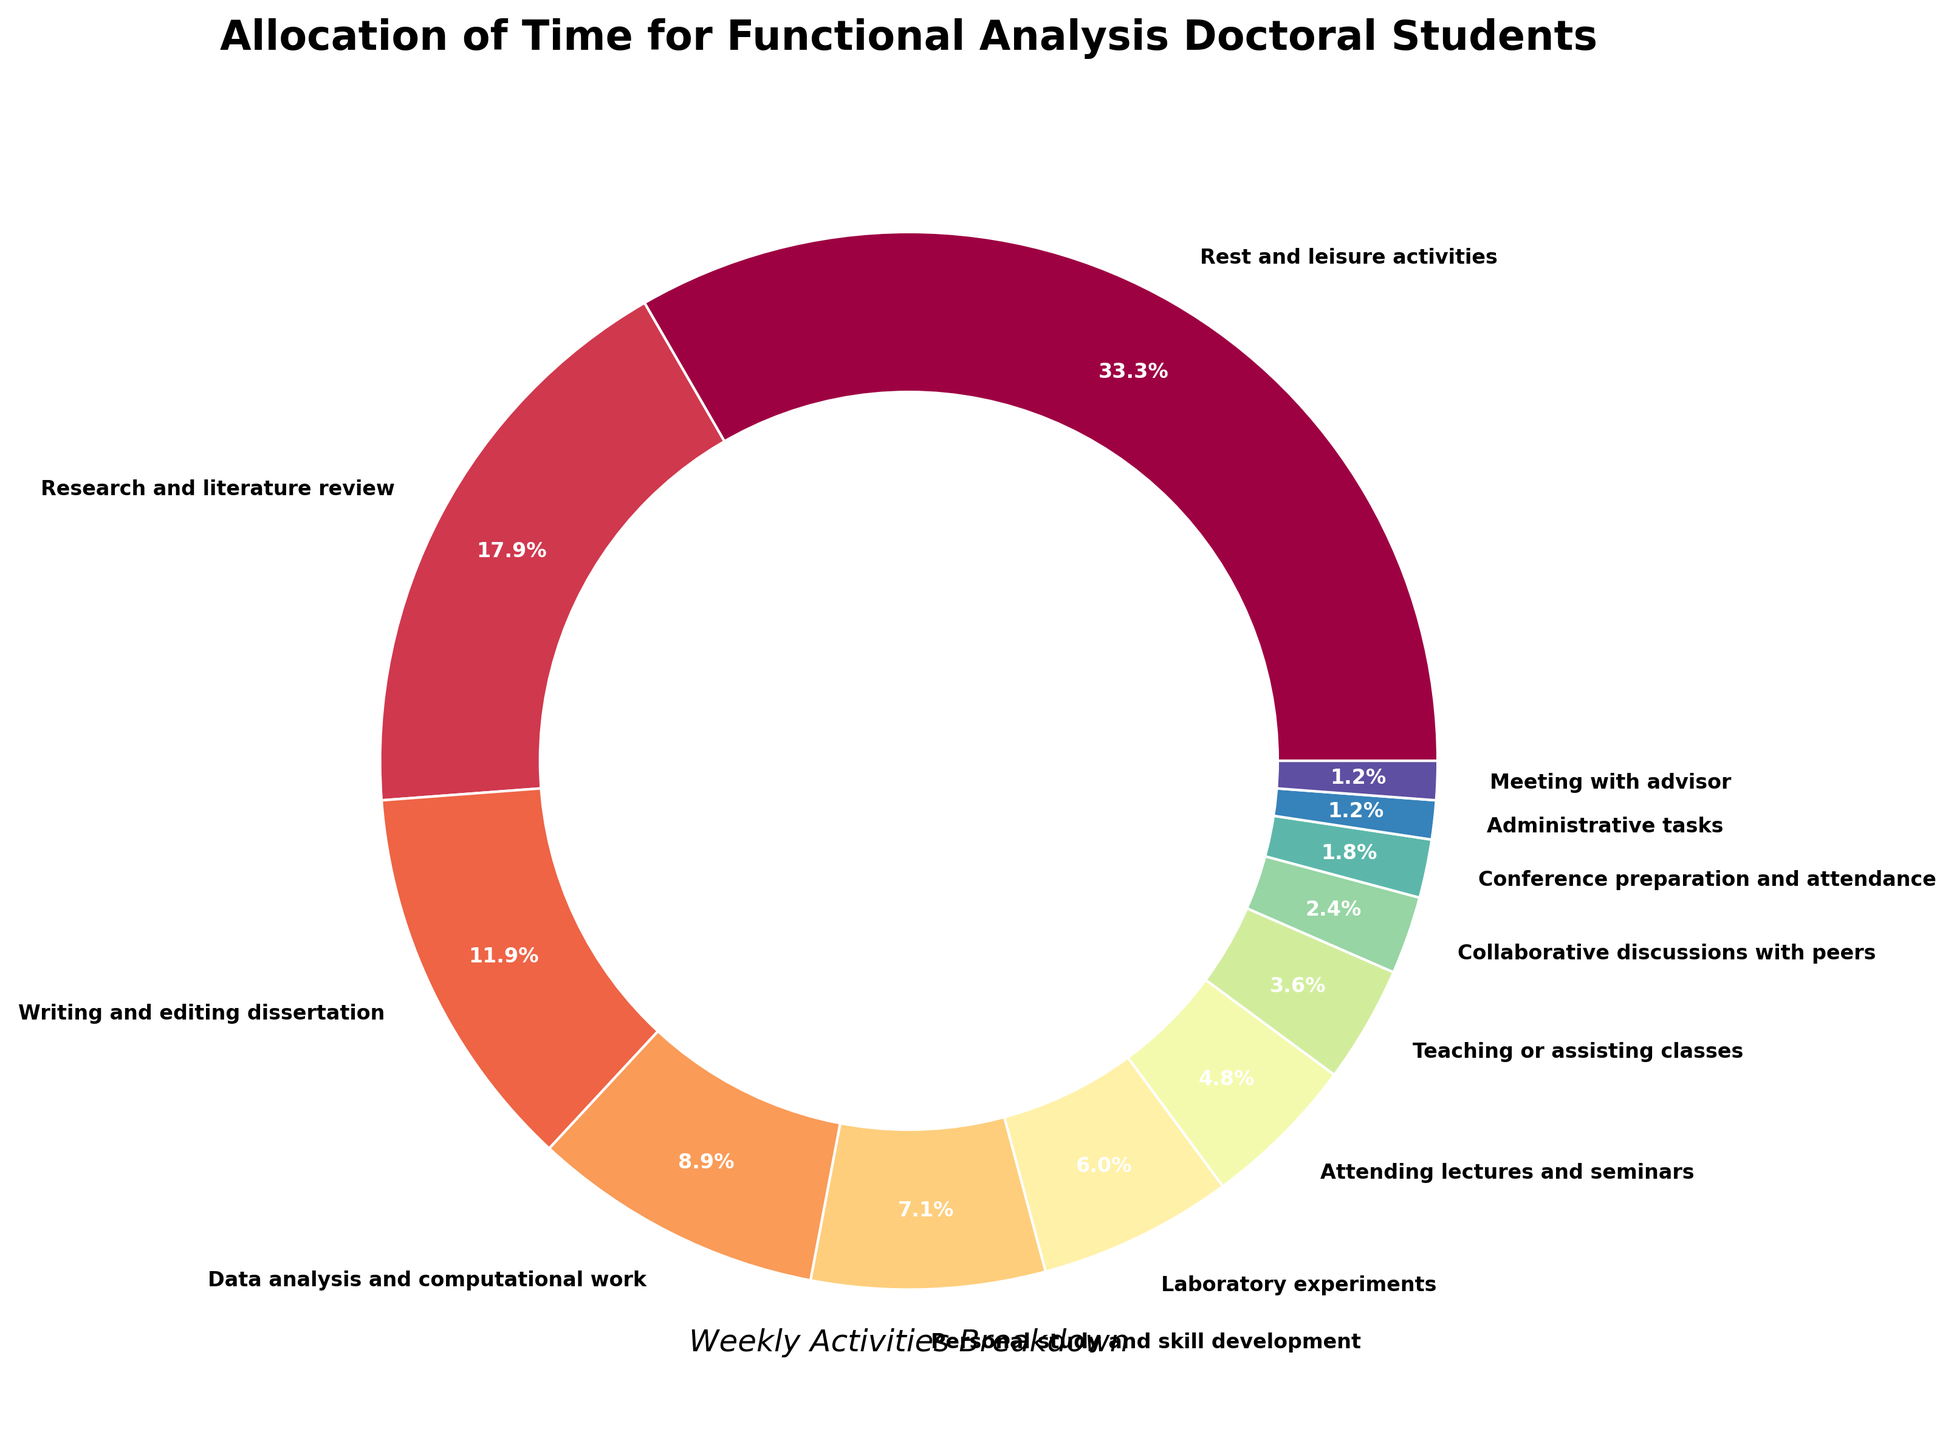What activity takes up the largest portion of time? The largest wedge in the pie chart represents "Rest and leisure activities", which is visually the largest section.
Answer: Rest and leisure activities Which two activities combined represent about as much time as writing and editing the dissertation? Writing and editing the dissertation takes 20 hours. "Data analysis and computational work" (15 hours) and "Meeting with advisor" (2 hours) together make 17 hours, which is about as much as writing and editing.
Answer: Data analysis and computational work, Meeting with advisor How much more time is spent on research and literature review compared to collaborative discussions with peers? Research and literature review takes up 30 hours while collaborative discussions with peers take 4 hours. The difference is 30 - 4 = 26 hours.
Answer: 26 hours What percentage of time is spent on both laboratory experiments and personal study combined? Laboratory experiments take up 10 hours and personal study and skill development takes 12 hours. The combined hours are 10 + 12 = 22 hours. Calculating the percentage: (22 / 168) * 100 ≈ 13.1%.
Answer: Approximately 13.1% What is the least time-consuming activity? The smallest wedge in the pie chart represents "Administrative tasks", occupying the least amount of time.
Answer: Administrative tasks Which activity, other than rest and leisure, consumes more time than attending lectures and seminars? "Attending lectures and seminars" takes 8 hours. Activities that consume more time are "Research and literature review" (30 hours), "Writing and editing dissertation" (20 hours), "Data analysis and computational work" (15 hours), "Laboratory experiments" (10 hours), and "Personal study and skill development" (12 hours).
Answer: Research and literature review, Writing and editing dissertation, Data analysis and computational work, Laboratory experiments, Personal study and skill development Which activities combined take up one third of the total weekly hours? The total weekly hours are 168. One third of 168 is 56 hours. "Rest and leisure activities" alone take 56 hours which is one third of the total weekly hours.
Answer: Rest and leisure activities Compare the time spent on teaching or assisting classes and meeting with advisor. Which one takes more time and by how many hours? "Teaching or assisting classes" takes 6 hours, whereas "Meeting with advisor" takes 2 hours. The difference is 6 - 2 = 4 hours.
Answer: Teaching or assisting classes, 4 hours What fraction of the total weekly hours is dedicated to attending lectures and seminars? Attending lectures and seminars takes up 8 hours out of a total of 168 hours. The fraction is 8/168, which simplifies to 1/21.
Answer: 1/21 